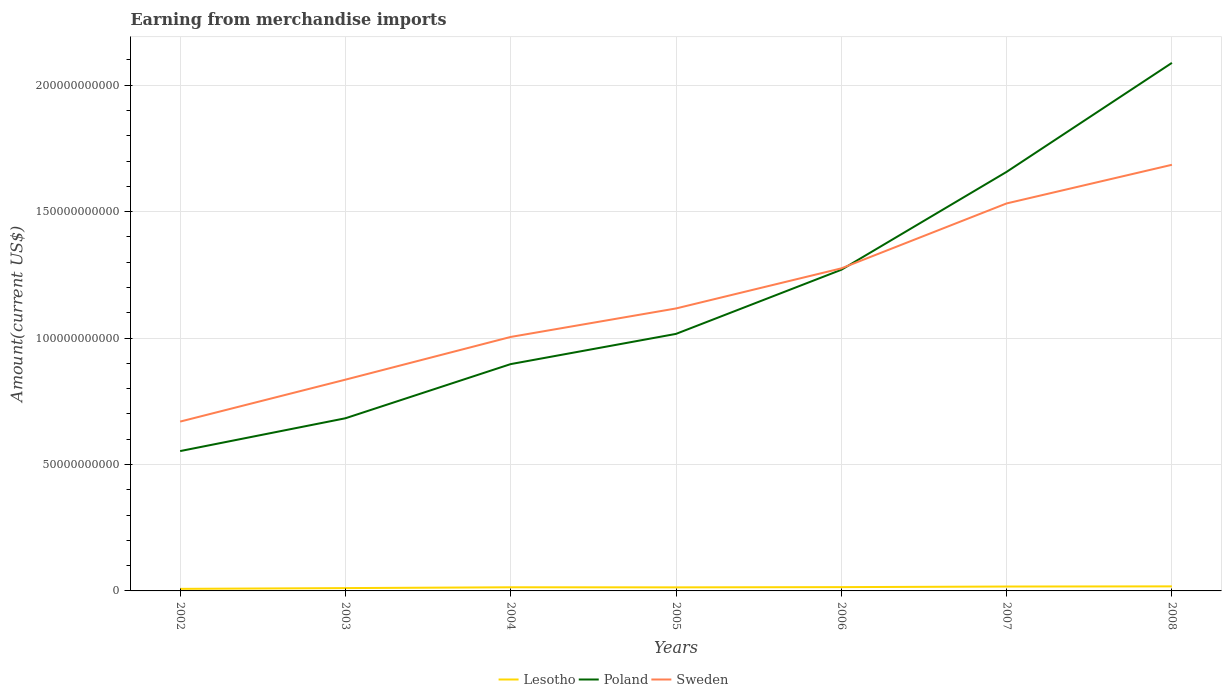Across all years, what is the maximum amount earned from merchandise imports in Poland?
Your response must be concise. 5.53e+1. What is the total amount earned from merchandise imports in Lesotho in the graph?
Provide a succinct answer. -2.98e+08. What is the difference between the highest and the second highest amount earned from merchandise imports in Poland?
Your answer should be compact. 1.54e+11. What is the difference between the highest and the lowest amount earned from merchandise imports in Sweden?
Make the answer very short. 3. How many lines are there?
Make the answer very short. 3. Does the graph contain grids?
Your response must be concise. Yes. Where does the legend appear in the graph?
Your answer should be compact. Bottom center. How many legend labels are there?
Keep it short and to the point. 3. What is the title of the graph?
Give a very brief answer. Earning from merchandise imports. Does "Gambia, The" appear as one of the legend labels in the graph?
Ensure brevity in your answer.  No. What is the label or title of the Y-axis?
Your answer should be very brief. Amount(current US$). What is the Amount(current US$) in Lesotho in 2002?
Your response must be concise. 8.15e+08. What is the Amount(current US$) of Poland in 2002?
Your answer should be compact. 5.53e+1. What is the Amount(current US$) of Sweden in 2002?
Give a very brief answer. 6.70e+1. What is the Amount(current US$) of Lesotho in 2003?
Offer a terse response. 1.12e+09. What is the Amount(current US$) of Poland in 2003?
Provide a succinct answer. 6.83e+1. What is the Amount(current US$) of Sweden in 2003?
Provide a succinct answer. 8.35e+1. What is the Amount(current US$) of Lesotho in 2004?
Offer a terse response. 1.44e+09. What is the Amount(current US$) of Poland in 2004?
Keep it short and to the point. 8.97e+1. What is the Amount(current US$) in Sweden in 2004?
Your answer should be very brief. 1.00e+11. What is the Amount(current US$) in Lesotho in 2005?
Keep it short and to the point. 1.41e+09. What is the Amount(current US$) of Poland in 2005?
Your answer should be compact. 1.02e+11. What is the Amount(current US$) of Sweden in 2005?
Offer a very short reply. 1.12e+11. What is the Amount(current US$) of Lesotho in 2006?
Give a very brief answer. 1.50e+09. What is the Amount(current US$) of Poland in 2006?
Make the answer very short. 1.27e+11. What is the Amount(current US$) in Sweden in 2006?
Keep it short and to the point. 1.28e+11. What is the Amount(current US$) of Lesotho in 2007?
Keep it short and to the point. 1.74e+09. What is the Amount(current US$) in Poland in 2007?
Ensure brevity in your answer.  1.66e+11. What is the Amount(current US$) of Sweden in 2007?
Give a very brief answer. 1.53e+11. What is the Amount(current US$) of Lesotho in 2008?
Your answer should be compact. 1.80e+09. What is the Amount(current US$) of Poland in 2008?
Your answer should be very brief. 2.09e+11. What is the Amount(current US$) in Sweden in 2008?
Provide a succinct answer. 1.69e+11. Across all years, what is the maximum Amount(current US$) of Lesotho?
Your answer should be compact. 1.80e+09. Across all years, what is the maximum Amount(current US$) in Poland?
Keep it short and to the point. 2.09e+11. Across all years, what is the maximum Amount(current US$) in Sweden?
Your response must be concise. 1.69e+11. Across all years, what is the minimum Amount(current US$) in Lesotho?
Offer a very short reply. 8.15e+08. Across all years, what is the minimum Amount(current US$) of Poland?
Your response must be concise. 5.53e+1. Across all years, what is the minimum Amount(current US$) of Sweden?
Offer a very short reply. 6.70e+1. What is the total Amount(current US$) in Lesotho in the graph?
Provide a succinct answer. 9.82e+09. What is the total Amount(current US$) in Poland in the graph?
Your answer should be compact. 8.16e+11. What is the total Amount(current US$) of Sweden in the graph?
Provide a short and direct response. 8.12e+11. What is the difference between the Amount(current US$) of Lesotho in 2002 and that in 2003?
Keep it short and to the point. -3.06e+08. What is the difference between the Amount(current US$) of Poland in 2002 and that in 2003?
Offer a terse response. -1.30e+1. What is the difference between the Amount(current US$) of Sweden in 2002 and that in 2003?
Offer a very short reply. -1.66e+1. What is the difference between the Amount(current US$) of Lesotho in 2002 and that in 2004?
Provide a succinct answer. -6.25e+08. What is the difference between the Amount(current US$) of Poland in 2002 and that in 2004?
Offer a very short reply. -3.44e+1. What is the difference between the Amount(current US$) of Sweden in 2002 and that in 2004?
Provide a short and direct response. -3.35e+1. What is the difference between the Amount(current US$) in Lesotho in 2002 and that in 2005?
Provide a short and direct response. -5.95e+08. What is the difference between the Amount(current US$) of Poland in 2002 and that in 2005?
Your answer should be compact. -4.63e+1. What is the difference between the Amount(current US$) of Sweden in 2002 and that in 2005?
Offer a very short reply. -4.47e+1. What is the difference between the Amount(current US$) in Lesotho in 2002 and that in 2006?
Your response must be concise. -6.85e+08. What is the difference between the Amount(current US$) of Poland in 2002 and that in 2006?
Offer a very short reply. -7.17e+1. What is the difference between the Amount(current US$) in Sweden in 2002 and that in 2006?
Offer a terse response. -6.06e+1. What is the difference between the Amount(current US$) in Lesotho in 2002 and that in 2007?
Provide a short and direct response. -9.23e+08. What is the difference between the Amount(current US$) in Poland in 2002 and that in 2007?
Offer a terse response. -1.10e+11. What is the difference between the Amount(current US$) of Sweden in 2002 and that in 2007?
Ensure brevity in your answer.  -8.63e+1. What is the difference between the Amount(current US$) in Lesotho in 2002 and that in 2008?
Keep it short and to the point. -9.85e+08. What is the difference between the Amount(current US$) of Poland in 2002 and that in 2008?
Keep it short and to the point. -1.54e+11. What is the difference between the Amount(current US$) of Sweden in 2002 and that in 2008?
Offer a very short reply. -1.02e+11. What is the difference between the Amount(current US$) of Lesotho in 2003 and that in 2004?
Provide a short and direct response. -3.19e+08. What is the difference between the Amount(current US$) in Poland in 2003 and that in 2004?
Your answer should be compact. -2.14e+1. What is the difference between the Amount(current US$) of Sweden in 2003 and that in 2004?
Ensure brevity in your answer.  -1.69e+1. What is the difference between the Amount(current US$) in Lesotho in 2003 and that in 2005?
Make the answer very short. -2.89e+08. What is the difference between the Amount(current US$) of Poland in 2003 and that in 2005?
Give a very brief answer. -3.34e+1. What is the difference between the Amount(current US$) in Sweden in 2003 and that in 2005?
Ensure brevity in your answer.  -2.82e+1. What is the difference between the Amount(current US$) of Lesotho in 2003 and that in 2006?
Provide a succinct answer. -3.79e+08. What is the difference between the Amount(current US$) of Poland in 2003 and that in 2006?
Keep it short and to the point. -5.87e+1. What is the difference between the Amount(current US$) of Sweden in 2003 and that in 2006?
Make the answer very short. -4.40e+1. What is the difference between the Amount(current US$) of Lesotho in 2003 and that in 2007?
Keep it short and to the point. -6.17e+08. What is the difference between the Amount(current US$) of Poland in 2003 and that in 2007?
Your answer should be compact. -9.74e+1. What is the difference between the Amount(current US$) of Sweden in 2003 and that in 2007?
Keep it short and to the point. -6.97e+1. What is the difference between the Amount(current US$) in Lesotho in 2003 and that in 2008?
Your answer should be compact. -6.79e+08. What is the difference between the Amount(current US$) of Poland in 2003 and that in 2008?
Ensure brevity in your answer.  -1.41e+11. What is the difference between the Amount(current US$) in Sweden in 2003 and that in 2008?
Keep it short and to the point. -8.50e+1. What is the difference between the Amount(current US$) in Lesotho in 2004 and that in 2005?
Your answer should be very brief. 2.99e+07. What is the difference between the Amount(current US$) in Poland in 2004 and that in 2005?
Offer a very short reply. -1.19e+1. What is the difference between the Amount(current US$) of Sweden in 2004 and that in 2005?
Make the answer very short. -1.13e+1. What is the difference between the Amount(current US$) of Lesotho in 2004 and that in 2006?
Your answer should be compact. -6.00e+07. What is the difference between the Amount(current US$) in Poland in 2004 and that in 2006?
Offer a very short reply. -3.73e+1. What is the difference between the Amount(current US$) in Sweden in 2004 and that in 2006?
Your response must be concise. -2.71e+1. What is the difference between the Amount(current US$) in Lesotho in 2004 and that in 2007?
Give a very brief answer. -2.98e+08. What is the difference between the Amount(current US$) in Poland in 2004 and that in 2007?
Provide a short and direct response. -7.60e+1. What is the difference between the Amount(current US$) in Sweden in 2004 and that in 2007?
Offer a terse response. -5.28e+1. What is the difference between the Amount(current US$) in Lesotho in 2004 and that in 2008?
Your response must be concise. -3.60e+08. What is the difference between the Amount(current US$) in Poland in 2004 and that in 2008?
Ensure brevity in your answer.  -1.19e+11. What is the difference between the Amount(current US$) in Sweden in 2004 and that in 2008?
Offer a terse response. -6.81e+1. What is the difference between the Amount(current US$) of Lesotho in 2005 and that in 2006?
Offer a terse response. -8.99e+07. What is the difference between the Amount(current US$) of Poland in 2005 and that in 2006?
Provide a short and direct response. -2.54e+1. What is the difference between the Amount(current US$) in Sweden in 2005 and that in 2006?
Provide a succinct answer. -1.59e+1. What is the difference between the Amount(current US$) in Lesotho in 2005 and that in 2007?
Make the answer very short. -3.28e+08. What is the difference between the Amount(current US$) in Poland in 2005 and that in 2007?
Your answer should be very brief. -6.41e+1. What is the difference between the Amount(current US$) of Sweden in 2005 and that in 2007?
Make the answer very short. -4.15e+1. What is the difference between the Amount(current US$) in Lesotho in 2005 and that in 2008?
Your answer should be compact. -3.90e+08. What is the difference between the Amount(current US$) of Poland in 2005 and that in 2008?
Your answer should be very brief. -1.07e+11. What is the difference between the Amount(current US$) in Sweden in 2005 and that in 2008?
Offer a very short reply. -5.68e+1. What is the difference between the Amount(current US$) of Lesotho in 2006 and that in 2007?
Make the answer very short. -2.38e+08. What is the difference between the Amount(current US$) of Poland in 2006 and that in 2007?
Offer a very short reply. -3.87e+1. What is the difference between the Amount(current US$) in Sweden in 2006 and that in 2007?
Make the answer very short. -2.57e+1. What is the difference between the Amount(current US$) of Lesotho in 2006 and that in 2008?
Give a very brief answer. -3.00e+08. What is the difference between the Amount(current US$) of Poland in 2006 and that in 2008?
Your answer should be compact. -8.18e+1. What is the difference between the Amount(current US$) in Sweden in 2006 and that in 2008?
Offer a terse response. -4.10e+1. What is the difference between the Amount(current US$) of Lesotho in 2007 and that in 2008?
Provide a succinct answer. -6.20e+07. What is the difference between the Amount(current US$) of Poland in 2007 and that in 2008?
Offer a very short reply. -4.31e+1. What is the difference between the Amount(current US$) of Sweden in 2007 and that in 2008?
Provide a short and direct response. -1.53e+1. What is the difference between the Amount(current US$) of Lesotho in 2002 and the Amount(current US$) of Poland in 2003?
Keep it short and to the point. -6.75e+1. What is the difference between the Amount(current US$) of Lesotho in 2002 and the Amount(current US$) of Sweden in 2003?
Your answer should be compact. -8.27e+1. What is the difference between the Amount(current US$) of Poland in 2002 and the Amount(current US$) of Sweden in 2003?
Offer a terse response. -2.82e+1. What is the difference between the Amount(current US$) of Lesotho in 2002 and the Amount(current US$) of Poland in 2004?
Your answer should be very brief. -8.89e+1. What is the difference between the Amount(current US$) of Lesotho in 2002 and the Amount(current US$) of Sweden in 2004?
Offer a very short reply. -9.96e+1. What is the difference between the Amount(current US$) of Poland in 2002 and the Amount(current US$) of Sweden in 2004?
Provide a short and direct response. -4.51e+1. What is the difference between the Amount(current US$) in Lesotho in 2002 and the Amount(current US$) in Poland in 2005?
Offer a very short reply. -1.01e+11. What is the difference between the Amount(current US$) in Lesotho in 2002 and the Amount(current US$) in Sweden in 2005?
Offer a very short reply. -1.11e+11. What is the difference between the Amount(current US$) of Poland in 2002 and the Amount(current US$) of Sweden in 2005?
Provide a succinct answer. -5.64e+1. What is the difference between the Amount(current US$) in Lesotho in 2002 and the Amount(current US$) in Poland in 2006?
Provide a short and direct response. -1.26e+11. What is the difference between the Amount(current US$) of Lesotho in 2002 and the Amount(current US$) of Sweden in 2006?
Ensure brevity in your answer.  -1.27e+11. What is the difference between the Amount(current US$) of Poland in 2002 and the Amount(current US$) of Sweden in 2006?
Give a very brief answer. -7.22e+1. What is the difference between the Amount(current US$) of Lesotho in 2002 and the Amount(current US$) of Poland in 2007?
Give a very brief answer. -1.65e+11. What is the difference between the Amount(current US$) of Lesotho in 2002 and the Amount(current US$) of Sweden in 2007?
Make the answer very short. -1.52e+11. What is the difference between the Amount(current US$) in Poland in 2002 and the Amount(current US$) in Sweden in 2007?
Your answer should be compact. -9.79e+1. What is the difference between the Amount(current US$) in Lesotho in 2002 and the Amount(current US$) in Poland in 2008?
Give a very brief answer. -2.08e+11. What is the difference between the Amount(current US$) in Lesotho in 2002 and the Amount(current US$) in Sweden in 2008?
Provide a succinct answer. -1.68e+11. What is the difference between the Amount(current US$) of Poland in 2002 and the Amount(current US$) of Sweden in 2008?
Offer a very short reply. -1.13e+11. What is the difference between the Amount(current US$) in Lesotho in 2003 and the Amount(current US$) in Poland in 2004?
Provide a short and direct response. -8.86e+1. What is the difference between the Amount(current US$) in Lesotho in 2003 and the Amount(current US$) in Sweden in 2004?
Keep it short and to the point. -9.93e+1. What is the difference between the Amount(current US$) of Poland in 2003 and the Amount(current US$) of Sweden in 2004?
Keep it short and to the point. -3.22e+1. What is the difference between the Amount(current US$) in Lesotho in 2003 and the Amount(current US$) in Poland in 2005?
Give a very brief answer. -1.01e+11. What is the difference between the Amount(current US$) in Lesotho in 2003 and the Amount(current US$) in Sweden in 2005?
Your answer should be compact. -1.11e+11. What is the difference between the Amount(current US$) in Poland in 2003 and the Amount(current US$) in Sweden in 2005?
Make the answer very short. -4.34e+1. What is the difference between the Amount(current US$) of Lesotho in 2003 and the Amount(current US$) of Poland in 2006?
Your answer should be compact. -1.26e+11. What is the difference between the Amount(current US$) of Lesotho in 2003 and the Amount(current US$) of Sweden in 2006?
Your answer should be compact. -1.26e+11. What is the difference between the Amount(current US$) in Poland in 2003 and the Amount(current US$) in Sweden in 2006?
Give a very brief answer. -5.93e+1. What is the difference between the Amount(current US$) in Lesotho in 2003 and the Amount(current US$) in Poland in 2007?
Your response must be concise. -1.65e+11. What is the difference between the Amount(current US$) of Lesotho in 2003 and the Amount(current US$) of Sweden in 2007?
Offer a very short reply. -1.52e+11. What is the difference between the Amount(current US$) in Poland in 2003 and the Amount(current US$) in Sweden in 2007?
Offer a terse response. -8.50e+1. What is the difference between the Amount(current US$) in Lesotho in 2003 and the Amount(current US$) in Poland in 2008?
Provide a short and direct response. -2.08e+11. What is the difference between the Amount(current US$) in Lesotho in 2003 and the Amount(current US$) in Sweden in 2008?
Provide a succinct answer. -1.67e+11. What is the difference between the Amount(current US$) in Poland in 2003 and the Amount(current US$) in Sweden in 2008?
Keep it short and to the point. -1.00e+11. What is the difference between the Amount(current US$) of Lesotho in 2004 and the Amount(current US$) of Poland in 2005?
Your response must be concise. -1.00e+11. What is the difference between the Amount(current US$) of Lesotho in 2004 and the Amount(current US$) of Sweden in 2005?
Offer a very short reply. -1.10e+11. What is the difference between the Amount(current US$) of Poland in 2004 and the Amount(current US$) of Sweden in 2005?
Provide a short and direct response. -2.20e+1. What is the difference between the Amount(current US$) of Lesotho in 2004 and the Amount(current US$) of Poland in 2006?
Provide a short and direct response. -1.26e+11. What is the difference between the Amount(current US$) of Lesotho in 2004 and the Amount(current US$) of Sweden in 2006?
Offer a very short reply. -1.26e+11. What is the difference between the Amount(current US$) in Poland in 2004 and the Amount(current US$) in Sweden in 2006?
Make the answer very short. -3.79e+1. What is the difference between the Amount(current US$) in Lesotho in 2004 and the Amount(current US$) in Poland in 2007?
Your answer should be compact. -1.64e+11. What is the difference between the Amount(current US$) in Lesotho in 2004 and the Amount(current US$) in Sweden in 2007?
Your answer should be compact. -1.52e+11. What is the difference between the Amount(current US$) in Poland in 2004 and the Amount(current US$) in Sweden in 2007?
Give a very brief answer. -6.35e+1. What is the difference between the Amount(current US$) of Lesotho in 2004 and the Amount(current US$) of Poland in 2008?
Your answer should be compact. -2.07e+11. What is the difference between the Amount(current US$) in Lesotho in 2004 and the Amount(current US$) in Sweden in 2008?
Ensure brevity in your answer.  -1.67e+11. What is the difference between the Amount(current US$) in Poland in 2004 and the Amount(current US$) in Sweden in 2008?
Your response must be concise. -7.88e+1. What is the difference between the Amount(current US$) in Lesotho in 2005 and the Amount(current US$) in Poland in 2006?
Your response must be concise. -1.26e+11. What is the difference between the Amount(current US$) of Lesotho in 2005 and the Amount(current US$) of Sweden in 2006?
Your response must be concise. -1.26e+11. What is the difference between the Amount(current US$) of Poland in 2005 and the Amount(current US$) of Sweden in 2006?
Your response must be concise. -2.59e+1. What is the difference between the Amount(current US$) in Lesotho in 2005 and the Amount(current US$) in Poland in 2007?
Ensure brevity in your answer.  -1.64e+11. What is the difference between the Amount(current US$) of Lesotho in 2005 and the Amount(current US$) of Sweden in 2007?
Your answer should be very brief. -1.52e+11. What is the difference between the Amount(current US$) of Poland in 2005 and the Amount(current US$) of Sweden in 2007?
Ensure brevity in your answer.  -5.16e+1. What is the difference between the Amount(current US$) in Lesotho in 2005 and the Amount(current US$) in Poland in 2008?
Give a very brief answer. -2.07e+11. What is the difference between the Amount(current US$) in Lesotho in 2005 and the Amount(current US$) in Sweden in 2008?
Offer a very short reply. -1.67e+11. What is the difference between the Amount(current US$) in Poland in 2005 and the Amount(current US$) in Sweden in 2008?
Your answer should be very brief. -6.69e+1. What is the difference between the Amount(current US$) of Lesotho in 2006 and the Amount(current US$) of Poland in 2007?
Keep it short and to the point. -1.64e+11. What is the difference between the Amount(current US$) of Lesotho in 2006 and the Amount(current US$) of Sweden in 2007?
Offer a very short reply. -1.52e+11. What is the difference between the Amount(current US$) of Poland in 2006 and the Amount(current US$) of Sweden in 2007?
Offer a terse response. -2.62e+1. What is the difference between the Amount(current US$) in Lesotho in 2006 and the Amount(current US$) in Poland in 2008?
Your answer should be compact. -2.07e+11. What is the difference between the Amount(current US$) in Lesotho in 2006 and the Amount(current US$) in Sweden in 2008?
Give a very brief answer. -1.67e+11. What is the difference between the Amount(current US$) in Poland in 2006 and the Amount(current US$) in Sweden in 2008?
Ensure brevity in your answer.  -4.15e+1. What is the difference between the Amount(current US$) of Lesotho in 2007 and the Amount(current US$) of Poland in 2008?
Provide a succinct answer. -2.07e+11. What is the difference between the Amount(current US$) in Lesotho in 2007 and the Amount(current US$) in Sweden in 2008?
Provide a succinct answer. -1.67e+11. What is the difference between the Amount(current US$) in Poland in 2007 and the Amount(current US$) in Sweden in 2008?
Make the answer very short. -2.79e+09. What is the average Amount(current US$) of Lesotho per year?
Your answer should be compact. 1.40e+09. What is the average Amount(current US$) in Poland per year?
Give a very brief answer. 1.17e+11. What is the average Amount(current US$) of Sweden per year?
Provide a short and direct response. 1.16e+11. In the year 2002, what is the difference between the Amount(current US$) in Lesotho and Amount(current US$) in Poland?
Offer a very short reply. -5.45e+1. In the year 2002, what is the difference between the Amount(current US$) in Lesotho and Amount(current US$) in Sweden?
Ensure brevity in your answer.  -6.61e+1. In the year 2002, what is the difference between the Amount(current US$) in Poland and Amount(current US$) in Sweden?
Your answer should be compact. -1.17e+1. In the year 2003, what is the difference between the Amount(current US$) in Lesotho and Amount(current US$) in Poland?
Offer a very short reply. -6.72e+1. In the year 2003, what is the difference between the Amount(current US$) in Lesotho and Amount(current US$) in Sweden?
Keep it short and to the point. -8.24e+1. In the year 2003, what is the difference between the Amount(current US$) in Poland and Amount(current US$) in Sweden?
Give a very brief answer. -1.53e+1. In the year 2004, what is the difference between the Amount(current US$) of Lesotho and Amount(current US$) of Poland?
Give a very brief answer. -8.83e+1. In the year 2004, what is the difference between the Amount(current US$) of Lesotho and Amount(current US$) of Sweden?
Make the answer very short. -9.90e+1. In the year 2004, what is the difference between the Amount(current US$) of Poland and Amount(current US$) of Sweden?
Keep it short and to the point. -1.07e+1. In the year 2005, what is the difference between the Amount(current US$) of Lesotho and Amount(current US$) of Poland?
Ensure brevity in your answer.  -1.00e+11. In the year 2005, what is the difference between the Amount(current US$) of Lesotho and Amount(current US$) of Sweden?
Keep it short and to the point. -1.10e+11. In the year 2005, what is the difference between the Amount(current US$) of Poland and Amount(current US$) of Sweden?
Keep it short and to the point. -1.01e+1. In the year 2006, what is the difference between the Amount(current US$) of Lesotho and Amount(current US$) of Poland?
Make the answer very short. -1.25e+11. In the year 2006, what is the difference between the Amount(current US$) in Lesotho and Amount(current US$) in Sweden?
Ensure brevity in your answer.  -1.26e+11. In the year 2006, what is the difference between the Amount(current US$) of Poland and Amount(current US$) of Sweden?
Offer a very short reply. -5.58e+08. In the year 2007, what is the difference between the Amount(current US$) of Lesotho and Amount(current US$) of Poland?
Your response must be concise. -1.64e+11. In the year 2007, what is the difference between the Amount(current US$) in Lesotho and Amount(current US$) in Sweden?
Offer a terse response. -1.51e+11. In the year 2007, what is the difference between the Amount(current US$) of Poland and Amount(current US$) of Sweden?
Offer a terse response. 1.25e+1. In the year 2008, what is the difference between the Amount(current US$) of Lesotho and Amount(current US$) of Poland?
Your answer should be very brief. -2.07e+11. In the year 2008, what is the difference between the Amount(current US$) of Lesotho and Amount(current US$) of Sweden?
Offer a terse response. -1.67e+11. In the year 2008, what is the difference between the Amount(current US$) in Poland and Amount(current US$) in Sweden?
Offer a very short reply. 4.03e+1. What is the ratio of the Amount(current US$) of Lesotho in 2002 to that in 2003?
Make the answer very short. 0.73. What is the ratio of the Amount(current US$) of Poland in 2002 to that in 2003?
Provide a succinct answer. 0.81. What is the ratio of the Amount(current US$) in Sweden in 2002 to that in 2003?
Keep it short and to the point. 0.8. What is the ratio of the Amount(current US$) of Lesotho in 2002 to that in 2004?
Offer a terse response. 0.57. What is the ratio of the Amount(current US$) in Poland in 2002 to that in 2004?
Your answer should be very brief. 0.62. What is the ratio of the Amount(current US$) in Lesotho in 2002 to that in 2005?
Your answer should be very brief. 0.58. What is the ratio of the Amount(current US$) of Poland in 2002 to that in 2005?
Ensure brevity in your answer.  0.54. What is the ratio of the Amount(current US$) in Sweden in 2002 to that in 2005?
Your response must be concise. 0.6. What is the ratio of the Amount(current US$) of Lesotho in 2002 to that in 2006?
Ensure brevity in your answer.  0.54. What is the ratio of the Amount(current US$) in Poland in 2002 to that in 2006?
Your response must be concise. 0.44. What is the ratio of the Amount(current US$) in Sweden in 2002 to that in 2006?
Your answer should be compact. 0.52. What is the ratio of the Amount(current US$) of Lesotho in 2002 to that in 2007?
Make the answer very short. 0.47. What is the ratio of the Amount(current US$) in Poland in 2002 to that in 2007?
Provide a short and direct response. 0.33. What is the ratio of the Amount(current US$) in Sweden in 2002 to that in 2007?
Provide a short and direct response. 0.44. What is the ratio of the Amount(current US$) of Lesotho in 2002 to that in 2008?
Offer a terse response. 0.45. What is the ratio of the Amount(current US$) in Poland in 2002 to that in 2008?
Make the answer very short. 0.26. What is the ratio of the Amount(current US$) of Sweden in 2002 to that in 2008?
Make the answer very short. 0.4. What is the ratio of the Amount(current US$) of Lesotho in 2003 to that in 2004?
Offer a very short reply. 0.78. What is the ratio of the Amount(current US$) of Poland in 2003 to that in 2004?
Provide a short and direct response. 0.76. What is the ratio of the Amount(current US$) in Sweden in 2003 to that in 2004?
Ensure brevity in your answer.  0.83. What is the ratio of the Amount(current US$) in Lesotho in 2003 to that in 2005?
Offer a very short reply. 0.8. What is the ratio of the Amount(current US$) in Poland in 2003 to that in 2005?
Your answer should be compact. 0.67. What is the ratio of the Amount(current US$) of Sweden in 2003 to that in 2005?
Ensure brevity in your answer.  0.75. What is the ratio of the Amount(current US$) in Lesotho in 2003 to that in 2006?
Keep it short and to the point. 0.75. What is the ratio of the Amount(current US$) in Poland in 2003 to that in 2006?
Your answer should be very brief. 0.54. What is the ratio of the Amount(current US$) in Sweden in 2003 to that in 2006?
Offer a very short reply. 0.66. What is the ratio of the Amount(current US$) of Lesotho in 2003 to that in 2007?
Give a very brief answer. 0.65. What is the ratio of the Amount(current US$) of Poland in 2003 to that in 2007?
Provide a short and direct response. 0.41. What is the ratio of the Amount(current US$) in Sweden in 2003 to that in 2007?
Provide a short and direct response. 0.55. What is the ratio of the Amount(current US$) of Lesotho in 2003 to that in 2008?
Make the answer very short. 0.62. What is the ratio of the Amount(current US$) of Poland in 2003 to that in 2008?
Make the answer very short. 0.33. What is the ratio of the Amount(current US$) of Sweden in 2003 to that in 2008?
Your answer should be very brief. 0.5. What is the ratio of the Amount(current US$) in Lesotho in 2004 to that in 2005?
Keep it short and to the point. 1.02. What is the ratio of the Amount(current US$) in Poland in 2004 to that in 2005?
Offer a very short reply. 0.88. What is the ratio of the Amount(current US$) of Sweden in 2004 to that in 2005?
Provide a succinct answer. 0.9. What is the ratio of the Amount(current US$) of Poland in 2004 to that in 2006?
Offer a very short reply. 0.71. What is the ratio of the Amount(current US$) of Sweden in 2004 to that in 2006?
Offer a terse response. 0.79. What is the ratio of the Amount(current US$) in Lesotho in 2004 to that in 2007?
Keep it short and to the point. 0.83. What is the ratio of the Amount(current US$) of Poland in 2004 to that in 2007?
Provide a succinct answer. 0.54. What is the ratio of the Amount(current US$) in Sweden in 2004 to that in 2007?
Ensure brevity in your answer.  0.66. What is the ratio of the Amount(current US$) in Poland in 2004 to that in 2008?
Your answer should be compact. 0.43. What is the ratio of the Amount(current US$) of Sweden in 2004 to that in 2008?
Ensure brevity in your answer.  0.6. What is the ratio of the Amount(current US$) in Lesotho in 2005 to that in 2006?
Keep it short and to the point. 0.94. What is the ratio of the Amount(current US$) in Poland in 2005 to that in 2006?
Ensure brevity in your answer.  0.8. What is the ratio of the Amount(current US$) of Sweden in 2005 to that in 2006?
Your answer should be very brief. 0.88. What is the ratio of the Amount(current US$) in Lesotho in 2005 to that in 2007?
Provide a short and direct response. 0.81. What is the ratio of the Amount(current US$) of Poland in 2005 to that in 2007?
Your answer should be compact. 0.61. What is the ratio of the Amount(current US$) in Sweden in 2005 to that in 2007?
Provide a short and direct response. 0.73. What is the ratio of the Amount(current US$) of Lesotho in 2005 to that in 2008?
Provide a succinct answer. 0.78. What is the ratio of the Amount(current US$) in Poland in 2005 to that in 2008?
Provide a succinct answer. 0.49. What is the ratio of the Amount(current US$) of Sweden in 2005 to that in 2008?
Ensure brevity in your answer.  0.66. What is the ratio of the Amount(current US$) of Lesotho in 2006 to that in 2007?
Your answer should be very brief. 0.86. What is the ratio of the Amount(current US$) of Poland in 2006 to that in 2007?
Your response must be concise. 0.77. What is the ratio of the Amount(current US$) in Sweden in 2006 to that in 2007?
Ensure brevity in your answer.  0.83. What is the ratio of the Amount(current US$) of Lesotho in 2006 to that in 2008?
Keep it short and to the point. 0.83. What is the ratio of the Amount(current US$) of Poland in 2006 to that in 2008?
Your answer should be compact. 0.61. What is the ratio of the Amount(current US$) of Sweden in 2006 to that in 2008?
Provide a short and direct response. 0.76. What is the ratio of the Amount(current US$) in Lesotho in 2007 to that in 2008?
Your answer should be compact. 0.97. What is the ratio of the Amount(current US$) of Poland in 2007 to that in 2008?
Offer a very short reply. 0.79. What is the ratio of the Amount(current US$) of Sweden in 2007 to that in 2008?
Give a very brief answer. 0.91. What is the difference between the highest and the second highest Amount(current US$) of Lesotho?
Your response must be concise. 6.20e+07. What is the difference between the highest and the second highest Amount(current US$) in Poland?
Provide a short and direct response. 4.31e+1. What is the difference between the highest and the second highest Amount(current US$) of Sweden?
Ensure brevity in your answer.  1.53e+1. What is the difference between the highest and the lowest Amount(current US$) in Lesotho?
Ensure brevity in your answer.  9.85e+08. What is the difference between the highest and the lowest Amount(current US$) of Poland?
Provide a succinct answer. 1.54e+11. What is the difference between the highest and the lowest Amount(current US$) of Sweden?
Offer a terse response. 1.02e+11. 